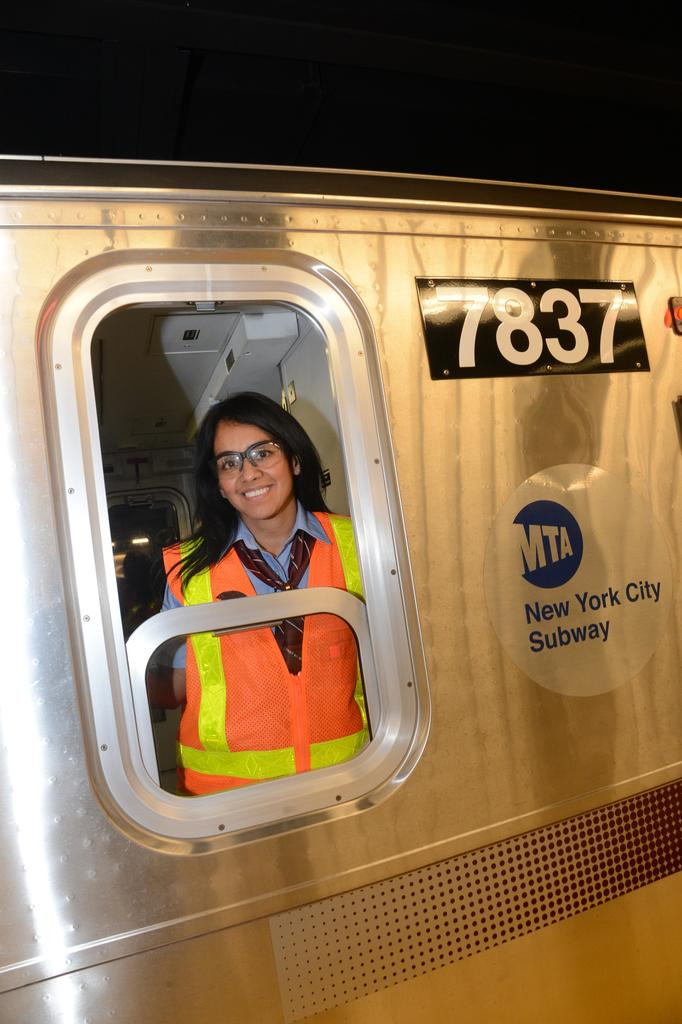What is the main subject of the image? There is a subway train in the image. Can you describe anything inside the train? A woman is visible through a window in the train. What is the woman wearing on her face? The woman is wearing spectacles. What type of clothing is the woman wearing? The woman is wearing a coat. How many tomatoes can be seen in the woman's hair in the image? There are no tomatoes present in the image, nor are there any tomatoes in the woman's hair. 